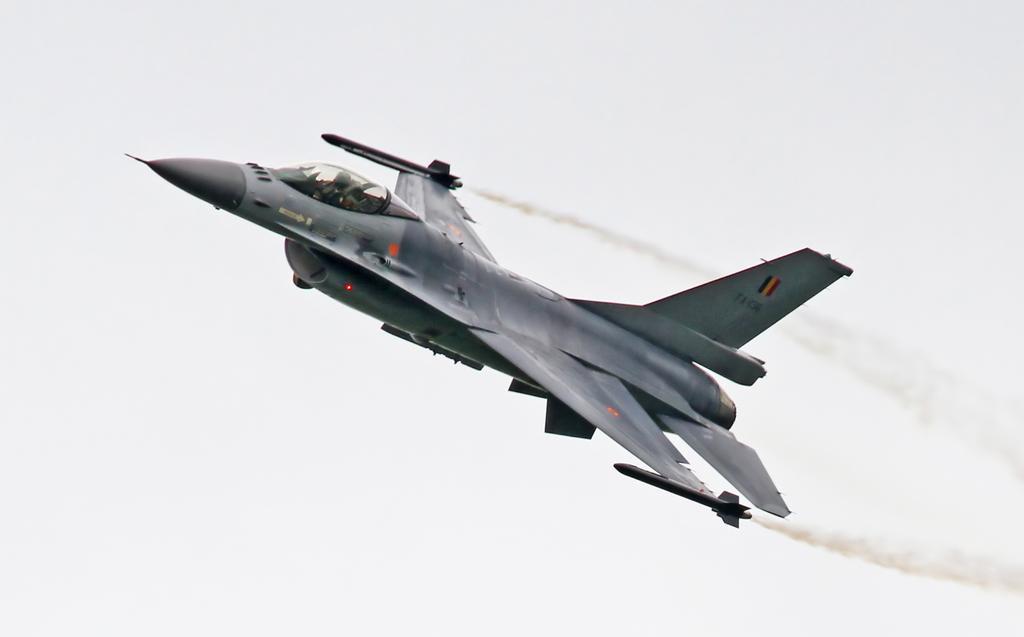Please provide a concise description of this image. In this image there is a jet plane flying in the air. The jet plane is releasing the smoke. There is a person in the jet plane. Background there is sky. 